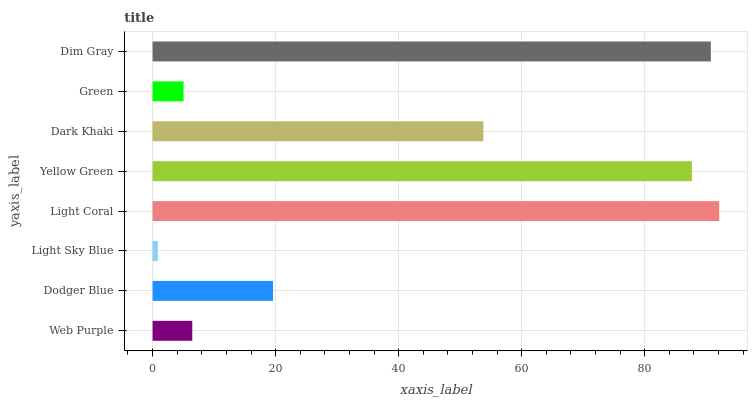Is Light Sky Blue the minimum?
Answer yes or no. Yes. Is Light Coral the maximum?
Answer yes or no. Yes. Is Dodger Blue the minimum?
Answer yes or no. No. Is Dodger Blue the maximum?
Answer yes or no. No. Is Dodger Blue greater than Web Purple?
Answer yes or no. Yes. Is Web Purple less than Dodger Blue?
Answer yes or no. Yes. Is Web Purple greater than Dodger Blue?
Answer yes or no. No. Is Dodger Blue less than Web Purple?
Answer yes or no. No. Is Dark Khaki the high median?
Answer yes or no. Yes. Is Dodger Blue the low median?
Answer yes or no. Yes. Is Dim Gray the high median?
Answer yes or no. No. Is Web Purple the low median?
Answer yes or no. No. 